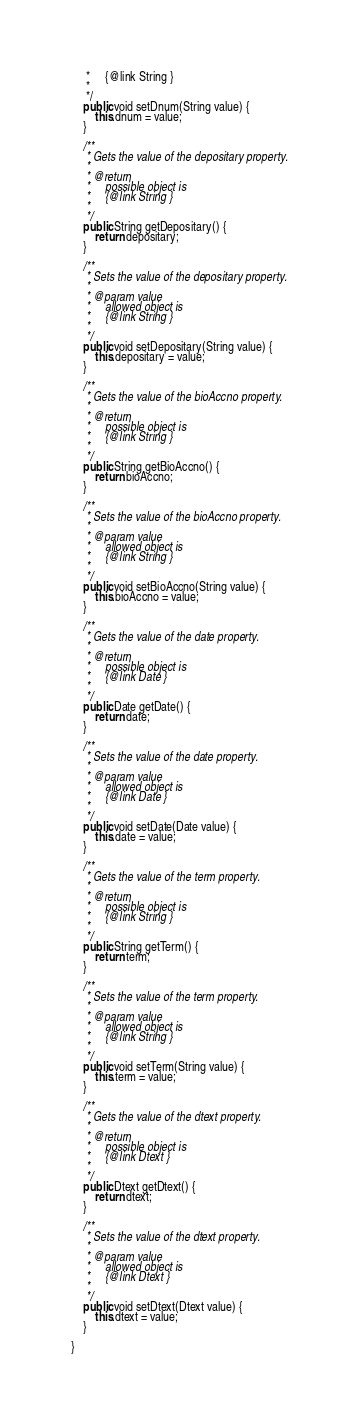Convert code to text. <code><loc_0><loc_0><loc_500><loc_500><_Java_>     *     {@link String }
     *     
     */
    public void setDnum(String value) {
        this.dnum = value;
    }

    /**
     * Gets the value of the depositary property.
     * 
     * @return
     *     possible object is
     *     {@link String }
     *     
     */
    public String getDepositary() {
        return depositary;
    }

    /**
     * Sets the value of the depositary property.
     * 
     * @param value
     *     allowed object is
     *     {@link String }
     *     
     */
    public void setDepositary(String value) {
        this.depositary = value;
    }

    /**
     * Gets the value of the bioAccno property.
     * 
     * @return
     *     possible object is
     *     {@link String }
     *     
     */
    public String getBioAccno() {
        return bioAccno;
    }

    /**
     * Sets the value of the bioAccno property.
     * 
     * @param value
     *     allowed object is
     *     {@link String }
     *     
     */
    public void setBioAccno(String value) {
        this.bioAccno = value;
    }

    /**
     * Gets the value of the date property.
     * 
     * @return
     *     possible object is
     *     {@link Date }
     *     
     */
    public Date getDate() {
        return date;
    }

    /**
     * Sets the value of the date property.
     * 
     * @param value
     *     allowed object is
     *     {@link Date }
     *     
     */
    public void setDate(Date value) {
        this.date = value;
    }

    /**
     * Gets the value of the term property.
     * 
     * @return
     *     possible object is
     *     {@link String }
     *     
     */
    public String getTerm() {
        return term;
    }

    /**
     * Sets the value of the term property.
     * 
     * @param value
     *     allowed object is
     *     {@link String }
     *     
     */
    public void setTerm(String value) {
        this.term = value;
    }

    /**
     * Gets the value of the dtext property.
     * 
     * @return
     *     possible object is
     *     {@link Dtext }
     *     
     */
    public Dtext getDtext() {
        return dtext;
    }

    /**
     * Sets the value of the dtext property.
     * 
     * @param value
     *     allowed object is
     *     {@link Dtext }
     *     
     */
    public void setDtext(Dtext value) {
        this.dtext = value;
    }

}
</code> 